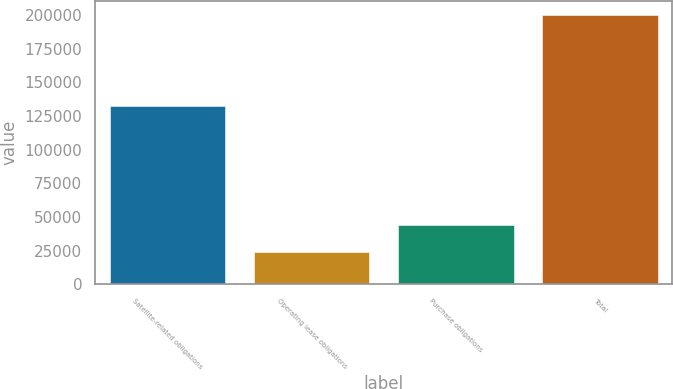<chart> <loc_0><loc_0><loc_500><loc_500><bar_chart><fcel>Satellite-related obligations<fcel>Operating lease obligations<fcel>Purchase obligations<fcel>Total<nl><fcel>132385<fcel>24168<fcel>43651<fcel>200204<nl></chart> 